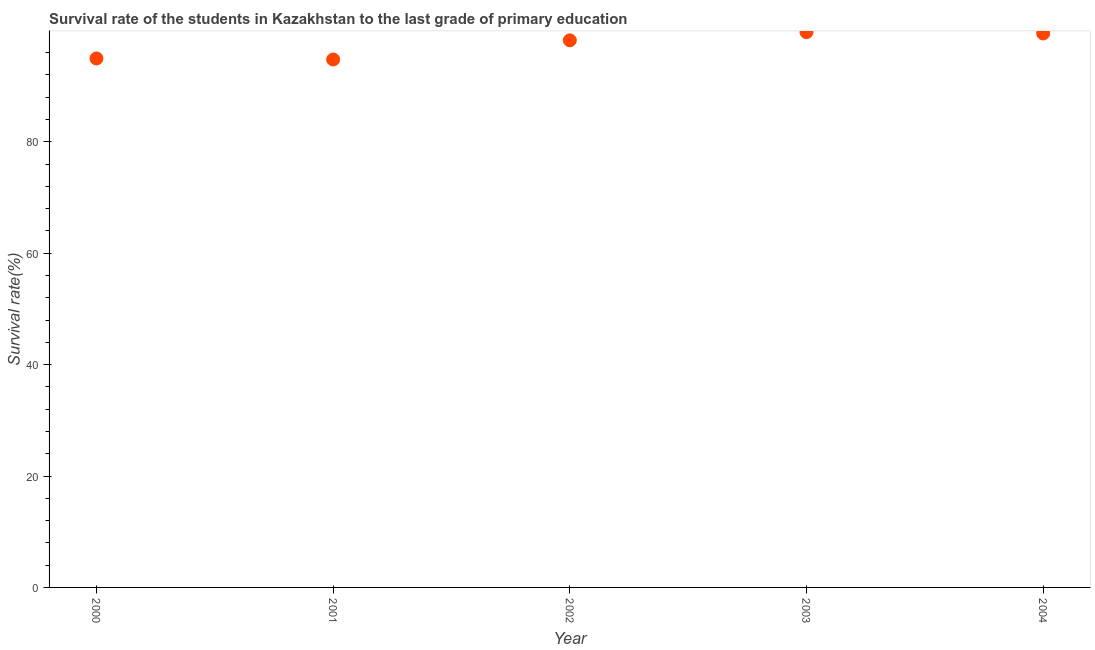What is the survival rate in primary education in 2001?
Make the answer very short. 94.77. Across all years, what is the maximum survival rate in primary education?
Ensure brevity in your answer.  99.67. Across all years, what is the minimum survival rate in primary education?
Make the answer very short. 94.77. In which year was the survival rate in primary education maximum?
Your response must be concise. 2003. What is the sum of the survival rate in primary education?
Offer a very short reply. 487.04. What is the difference between the survival rate in primary education in 2000 and 2003?
Offer a very short reply. -4.72. What is the average survival rate in primary education per year?
Make the answer very short. 97.41. What is the median survival rate in primary education?
Provide a succinct answer. 98.21. Do a majority of the years between 2004 and 2002 (inclusive) have survival rate in primary education greater than 80 %?
Offer a very short reply. No. What is the ratio of the survival rate in primary education in 2000 to that in 2003?
Ensure brevity in your answer.  0.95. Is the survival rate in primary education in 2001 less than that in 2003?
Your response must be concise. Yes. What is the difference between the highest and the second highest survival rate in primary education?
Your answer should be very brief. 0.23. What is the difference between the highest and the lowest survival rate in primary education?
Offer a terse response. 4.9. In how many years, is the survival rate in primary education greater than the average survival rate in primary education taken over all years?
Provide a succinct answer. 3. Does the survival rate in primary education monotonically increase over the years?
Provide a succinct answer. No. How many dotlines are there?
Your answer should be very brief. 1. Does the graph contain grids?
Your response must be concise. No. What is the title of the graph?
Offer a terse response. Survival rate of the students in Kazakhstan to the last grade of primary education. What is the label or title of the Y-axis?
Make the answer very short. Survival rate(%). What is the Survival rate(%) in 2000?
Provide a short and direct response. 94.95. What is the Survival rate(%) in 2001?
Offer a terse response. 94.77. What is the Survival rate(%) in 2002?
Ensure brevity in your answer.  98.21. What is the Survival rate(%) in 2003?
Provide a short and direct response. 99.67. What is the Survival rate(%) in 2004?
Keep it short and to the point. 99.44. What is the difference between the Survival rate(%) in 2000 and 2001?
Your answer should be compact. 0.19. What is the difference between the Survival rate(%) in 2000 and 2002?
Ensure brevity in your answer.  -3.25. What is the difference between the Survival rate(%) in 2000 and 2003?
Make the answer very short. -4.72. What is the difference between the Survival rate(%) in 2000 and 2004?
Make the answer very short. -4.49. What is the difference between the Survival rate(%) in 2001 and 2002?
Your response must be concise. -3.44. What is the difference between the Survival rate(%) in 2001 and 2003?
Your response must be concise. -4.9. What is the difference between the Survival rate(%) in 2001 and 2004?
Keep it short and to the point. -4.67. What is the difference between the Survival rate(%) in 2002 and 2003?
Offer a very short reply. -1.46. What is the difference between the Survival rate(%) in 2002 and 2004?
Your response must be concise. -1.23. What is the difference between the Survival rate(%) in 2003 and 2004?
Give a very brief answer. 0.23. What is the ratio of the Survival rate(%) in 2000 to that in 2003?
Offer a very short reply. 0.95. What is the ratio of the Survival rate(%) in 2000 to that in 2004?
Ensure brevity in your answer.  0.95. What is the ratio of the Survival rate(%) in 2001 to that in 2002?
Your response must be concise. 0.96. What is the ratio of the Survival rate(%) in 2001 to that in 2003?
Provide a succinct answer. 0.95. What is the ratio of the Survival rate(%) in 2001 to that in 2004?
Ensure brevity in your answer.  0.95. 